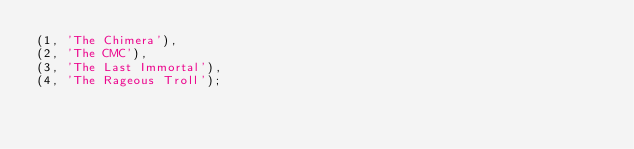<code> <loc_0><loc_0><loc_500><loc_500><_SQL_>(1, 'The Chimera'),
(2, 'The CMC'),
(3, 'The Last Immortal'),
(4, 'The Rageous Troll');
</code> 